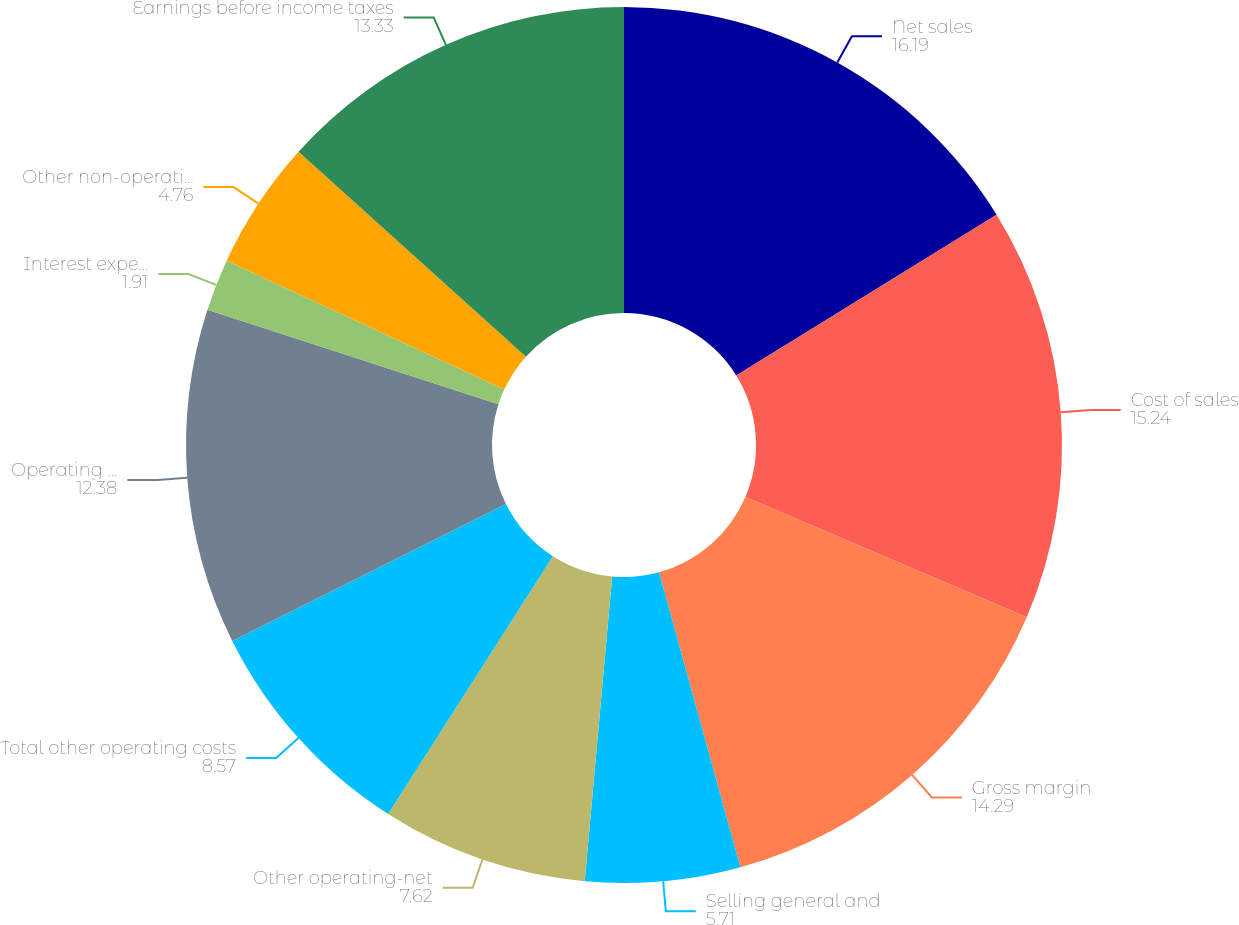Convert chart to OTSL. <chart><loc_0><loc_0><loc_500><loc_500><pie_chart><fcel>Net sales<fcel>Cost of sales<fcel>Gross margin<fcel>Selling general and<fcel>Other operating-net<fcel>Total other operating costs<fcel>Operating earnings<fcel>Interest expense (income)-net<fcel>Other non-operating-net<fcel>Earnings before income taxes<nl><fcel>16.19%<fcel>15.24%<fcel>14.29%<fcel>5.71%<fcel>7.62%<fcel>8.57%<fcel>12.38%<fcel>1.91%<fcel>4.76%<fcel>13.33%<nl></chart> 